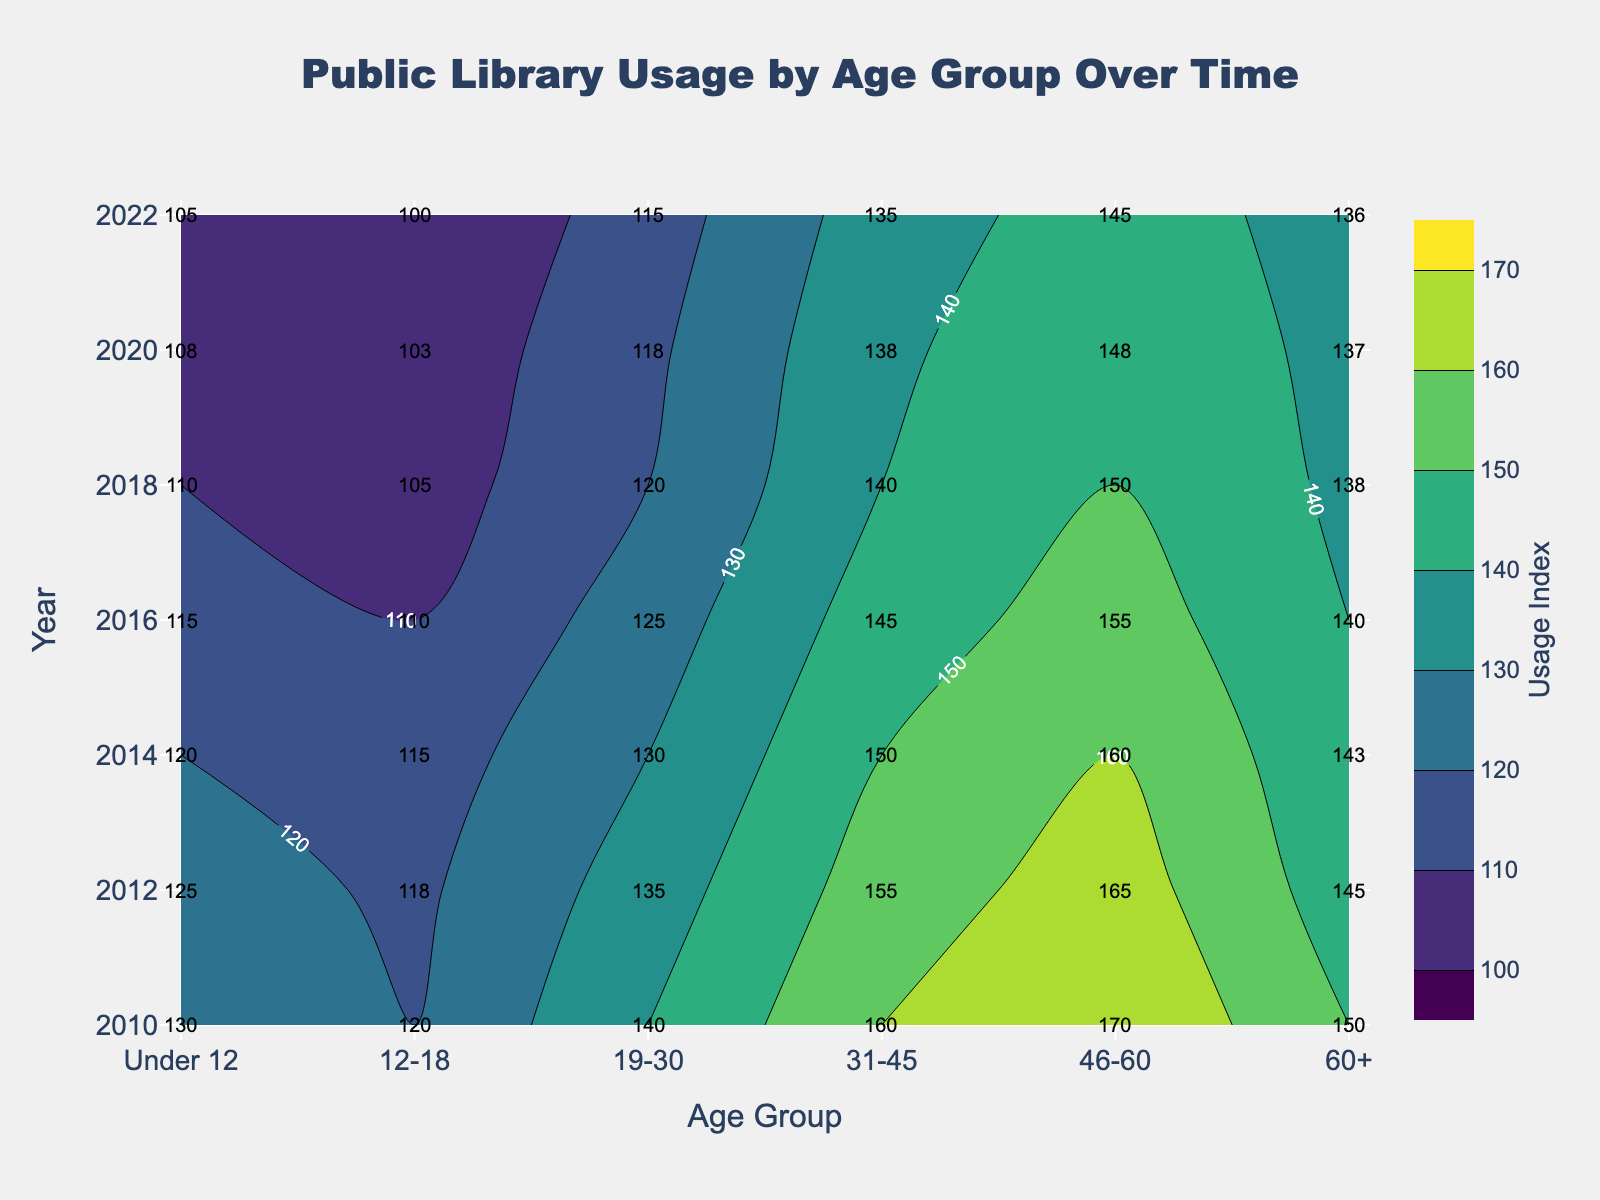What's the title of the figure? The title is typically displayed at the top of the figure and indicates the main topic. In this case, it is positioned at the top center of the plot.
Answer: Public Library Usage by Age Group Over Time What are the labels on the x-axis and y-axis? The x-axis and y-axis labels provide the context for the figure's data. In this case, they are displayed on the sides of the plot.
Answer: Age Group (x-axis) and Year (y-axis) How does the usage index for the 'Under 12' age group change from 2010 to 2022? By looking at the labeled contour lines for the 'Under 12' age group along the x-axis and comparing the values from 2010 to 2022, we can see how it varies over time.
Answer: It decreases Which year has the highest usage index for the '46-60' age group? To find this, we need to look at the contour lines for the '46-60' age group and identify the year with the highest labeled value.
Answer: 2010 What is the trend in the usage index for the '19-30' age group over the years? We observe the contour lines for the '19-30' age group and note how the values change over time from 2010 to 2022.
Answer: Decreasing Which age group shows the least variation in usage index over the years? By comparing the range of usage index values for each age group across all years, we can identify the group with the smallest range.
Answer: 'Under 12' What is the difference in the usage index between the '60+' and '19-30' age groups in 2018? By locating the labels for the '60+' and '19-30' age groups in the year 2018 along the x-axis, we subtract the value for '19-30' from '60+'.
Answer: 45 (150 - 105) Which age group had the largest drop in usage index between 2010 and 2022? By noting the values for each age group in 2010 and 2022 and calculating the difference, we determine which had the biggest decline.
Answer: '19-30' Is there any age group with an increasing usage index trend over the years? We look at the contour plot to identify any age group whose usage index values consistently increase from 2010 to 2022.
Answer: No Which age group had the highest usage index in 2022? By examining the labeled values for all age groups in the year 2022, we can determine which one is the highest.
Answer: '60+' 